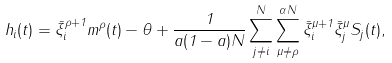Convert formula to latex. <formula><loc_0><loc_0><loc_500><loc_500>h _ { i } ( t ) = \bar { \xi } _ { i } ^ { \rho + 1 } m ^ { \rho } ( t ) - \theta + \frac { 1 } { a ( 1 - a ) N } \sum _ { j \ne i } ^ { N } \sum _ { \mu \ne \rho } ^ { \alpha N } \bar { \xi } _ { i } ^ { \mu + 1 } \bar { \xi } _ { j } ^ { \mu } S _ { j } ( t ) ,</formula> 